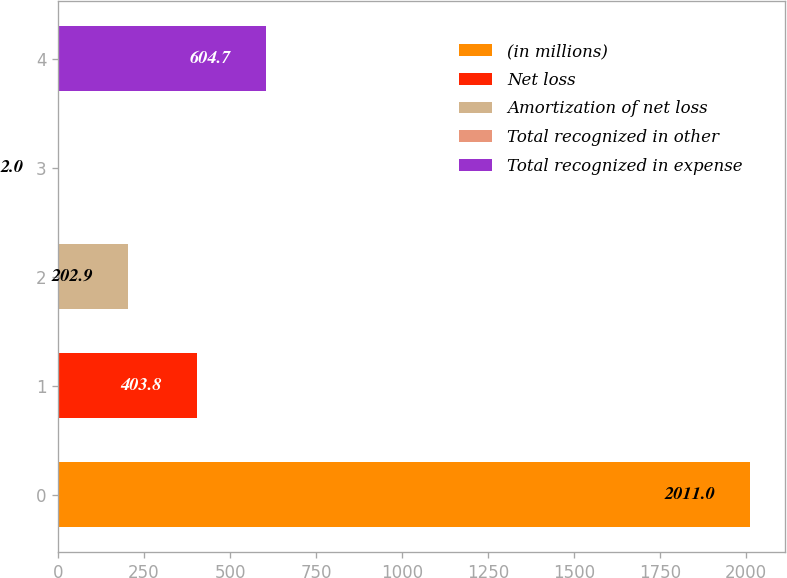<chart> <loc_0><loc_0><loc_500><loc_500><bar_chart><fcel>(in millions)<fcel>Net loss<fcel>Amortization of net loss<fcel>Total recognized in other<fcel>Total recognized in expense<nl><fcel>2011<fcel>403.8<fcel>202.9<fcel>2<fcel>604.7<nl></chart> 